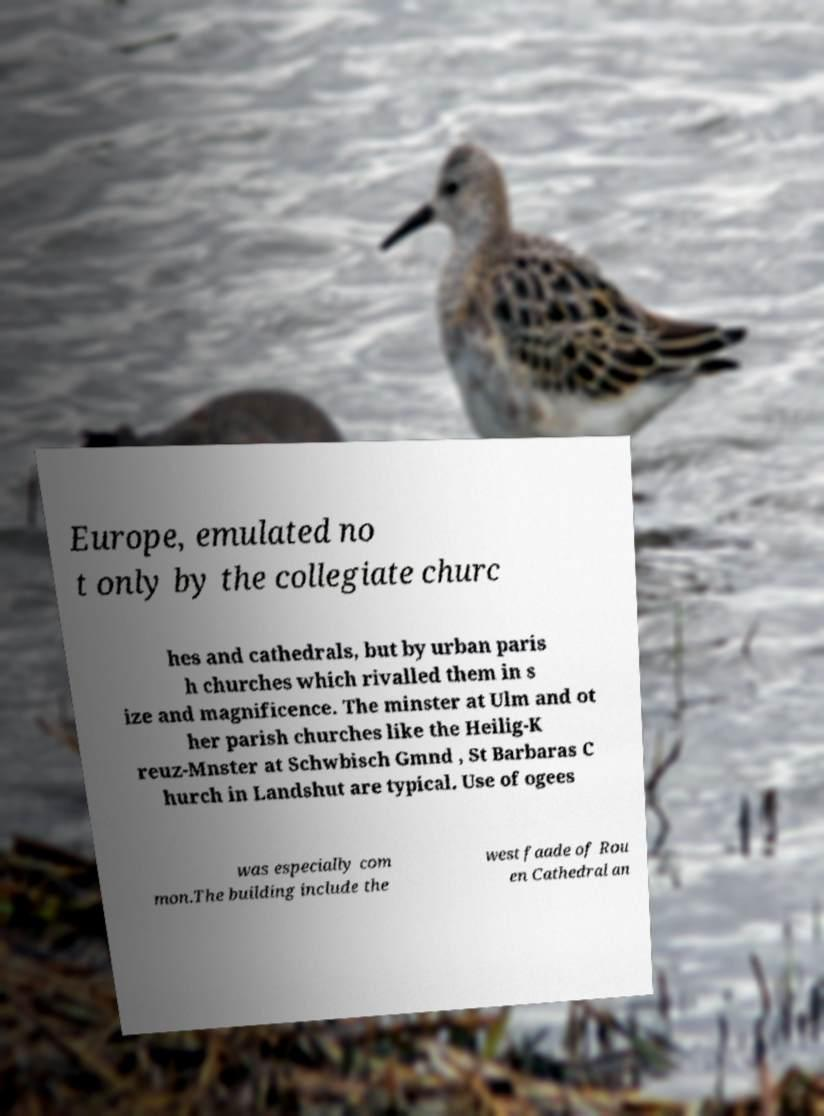Can you accurately transcribe the text from the provided image for me? Europe, emulated no t only by the collegiate churc hes and cathedrals, but by urban paris h churches which rivalled them in s ize and magnificence. The minster at Ulm and ot her parish churches like the Heilig-K reuz-Mnster at Schwbisch Gmnd , St Barbaras C hurch in Landshut are typical. Use of ogees was especially com mon.The building include the west faade of Rou en Cathedral an 